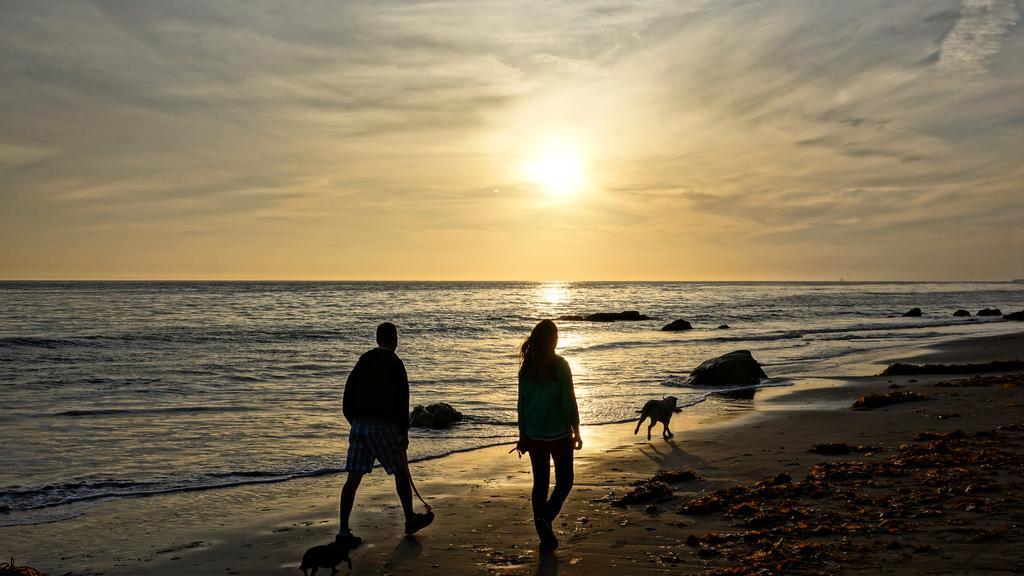Can you describe this image briefly? In the center of the image we can see persons and dog walking on the sand. In the background there is sea, sky, clouds and sun. 